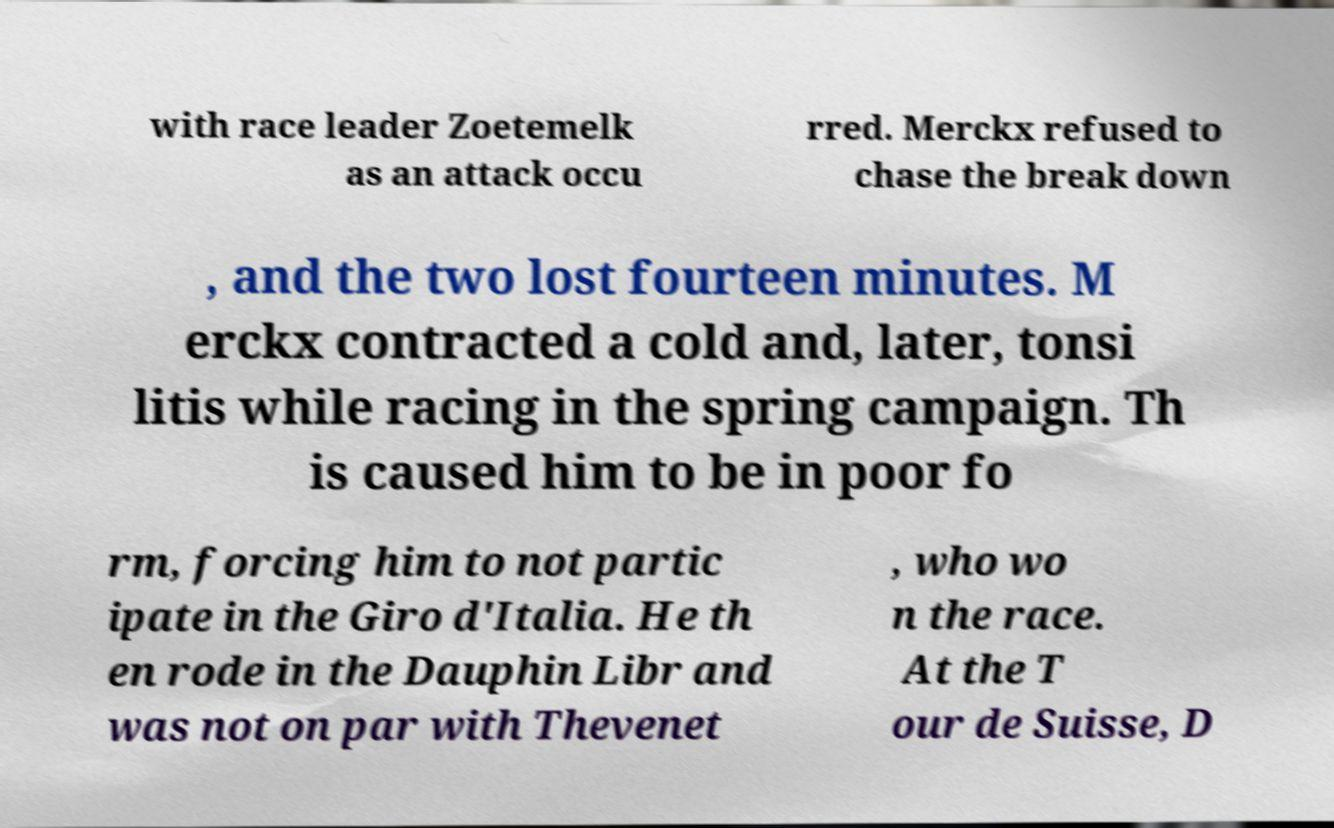There's text embedded in this image that I need extracted. Can you transcribe it verbatim? with race leader Zoetemelk as an attack occu rred. Merckx refused to chase the break down , and the two lost fourteen minutes. M erckx contracted a cold and, later, tonsi litis while racing in the spring campaign. Th is caused him to be in poor fo rm, forcing him to not partic ipate in the Giro d'Italia. He th en rode in the Dauphin Libr and was not on par with Thevenet , who wo n the race. At the T our de Suisse, D 